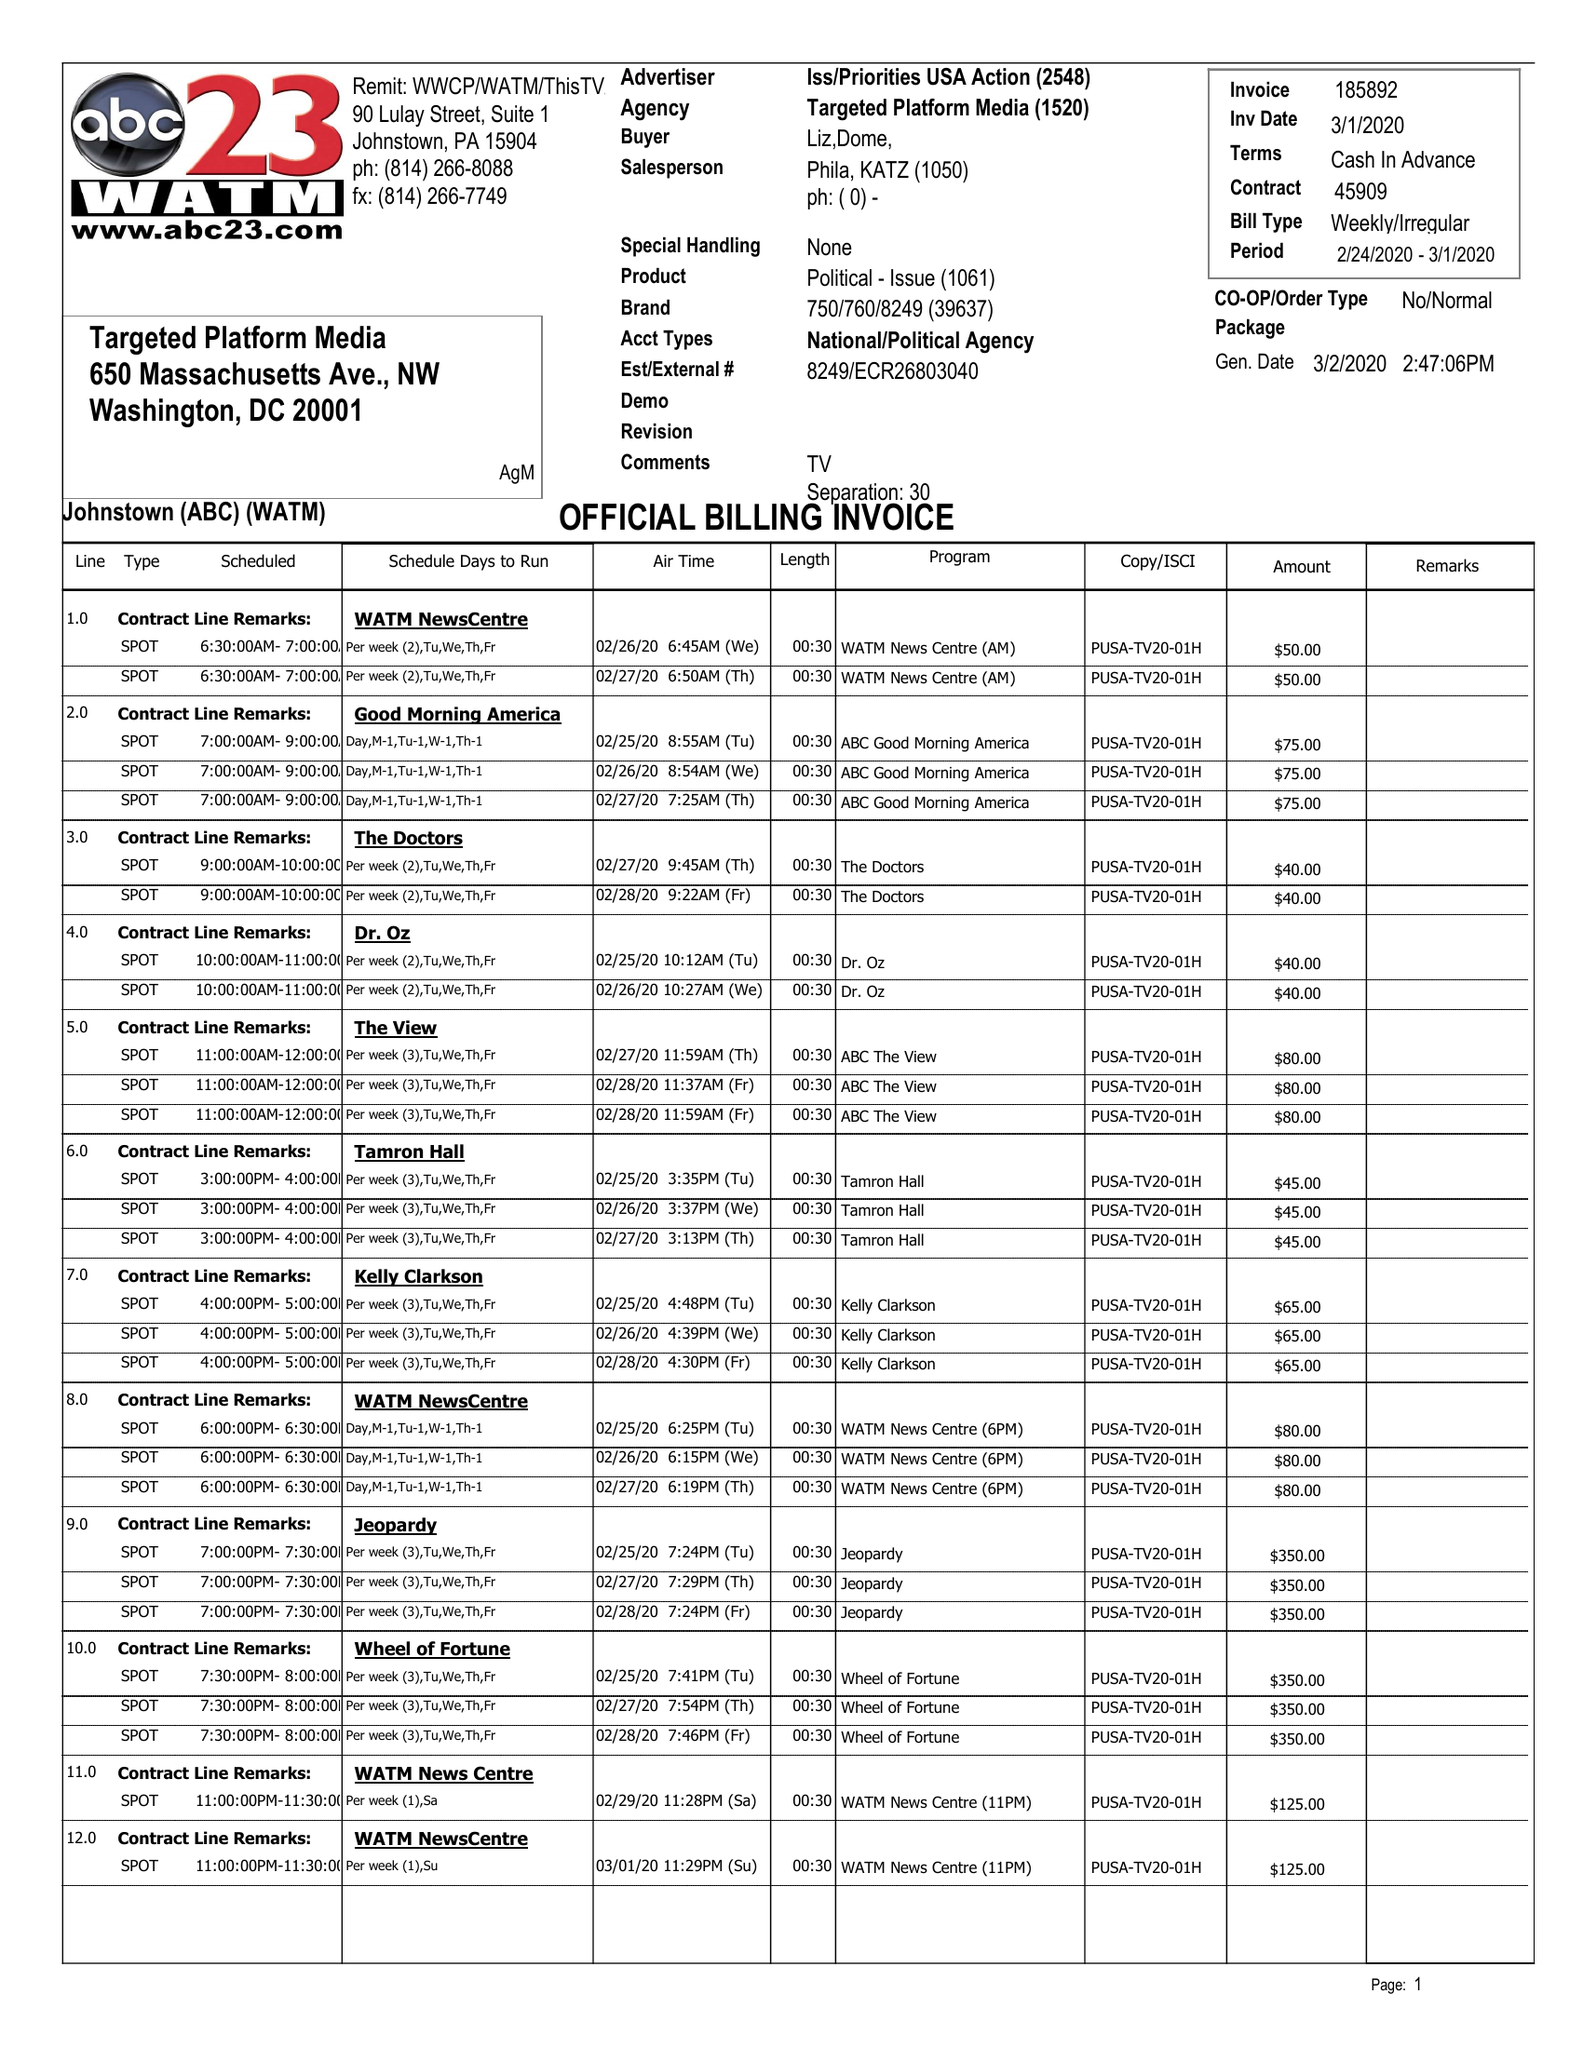What is the value for the gross_amount?
Answer the question using a single word or phrase. 25720.00 